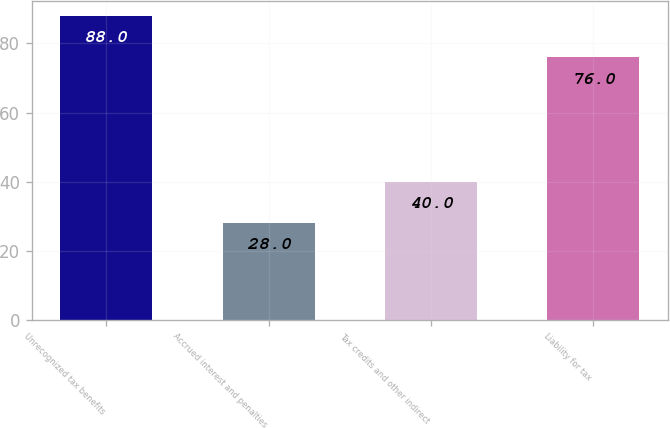Convert chart. <chart><loc_0><loc_0><loc_500><loc_500><bar_chart><fcel>Unrecognized tax benefits<fcel>Accrued interest and penalties<fcel>Tax credits and other indirect<fcel>Liability for tax<nl><fcel>88<fcel>28<fcel>40<fcel>76<nl></chart> 